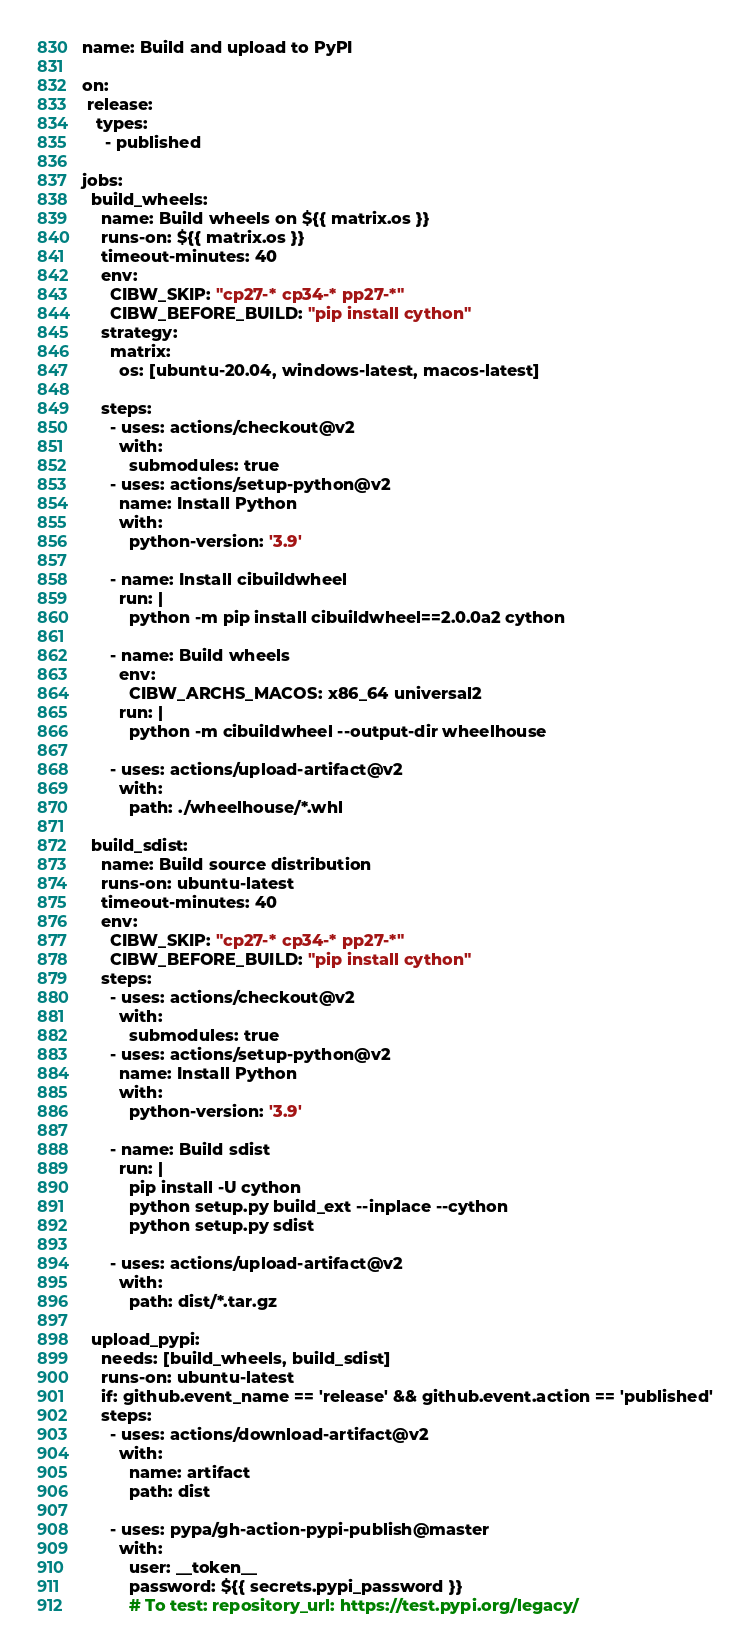Convert code to text. <code><loc_0><loc_0><loc_500><loc_500><_YAML_>name: Build and upload to PyPI

on:
 release:
   types:
     - published

jobs:
  build_wheels:
    name: Build wheels on ${{ matrix.os }}
    runs-on: ${{ matrix.os }}
    timeout-minutes: 40
    env:
      CIBW_SKIP: "cp27-* cp34-* pp27-*"
      CIBW_BEFORE_BUILD: "pip install cython"
    strategy:
      matrix:
        os: [ubuntu-20.04, windows-latest, macos-latest]

    steps:
      - uses: actions/checkout@v2
        with:
          submodules: true
      - uses: actions/setup-python@v2
        name: Install Python
        with:
          python-version: '3.9'

      - name: Install cibuildwheel
        run: |
          python -m pip install cibuildwheel==2.0.0a2 cython

      - name: Build wheels
        env:
          CIBW_ARCHS_MACOS: x86_64 universal2
        run: |
          python -m cibuildwheel --output-dir wheelhouse

      - uses: actions/upload-artifact@v2
        with:
          path: ./wheelhouse/*.whl

  build_sdist:
    name: Build source distribution
    runs-on: ubuntu-latest
    timeout-minutes: 40
    env:
      CIBW_SKIP: "cp27-* cp34-* pp27-*"
      CIBW_BEFORE_BUILD: "pip install cython"
    steps:
      - uses: actions/checkout@v2
        with:
          submodules: true
      - uses: actions/setup-python@v2
        name: Install Python
        with:
          python-version: '3.9'

      - name: Build sdist
        run: |
          pip install -U cython
          python setup.py build_ext --inplace --cython
          python setup.py sdist

      - uses: actions/upload-artifact@v2
        with:
          path: dist/*.tar.gz

  upload_pypi:
    needs: [build_wheels, build_sdist]
    runs-on: ubuntu-latest
    if: github.event_name == 'release' && github.event.action == 'published'
    steps:
      - uses: actions/download-artifact@v2
        with:
          name: artifact
          path: dist

      - uses: pypa/gh-action-pypi-publish@master
        with:
          user: __token__
          password: ${{ secrets.pypi_password }}
          # To test: repository_url: https://test.pypi.org/legacy/
</code> 